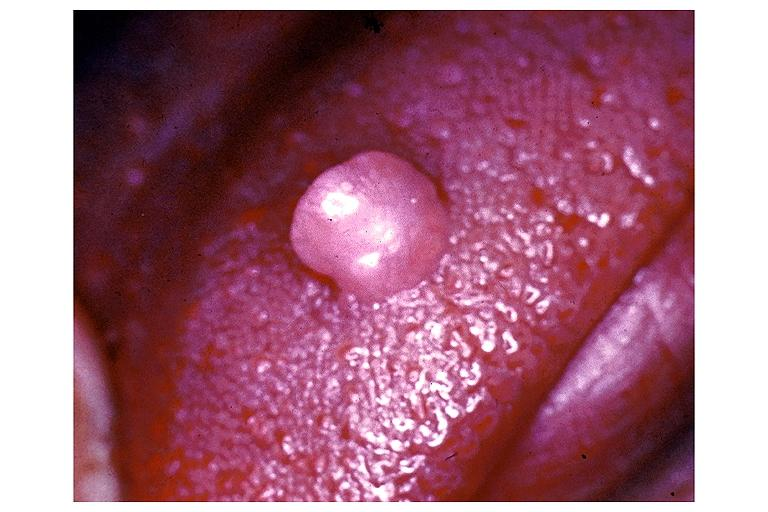what does this image show?
Answer the question using a single word or phrase. Irritation fibroma 